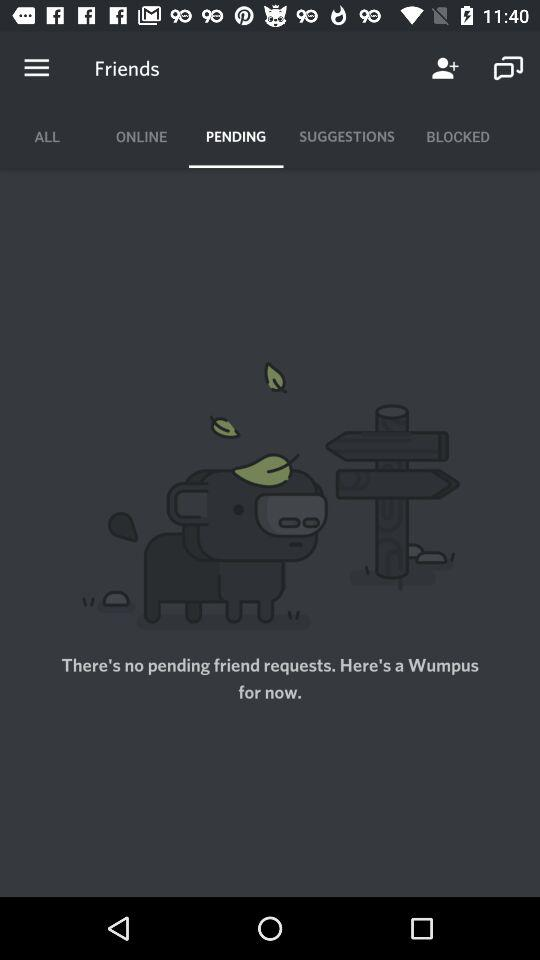Is there any pending friend requests? There is no pending friend requests. 